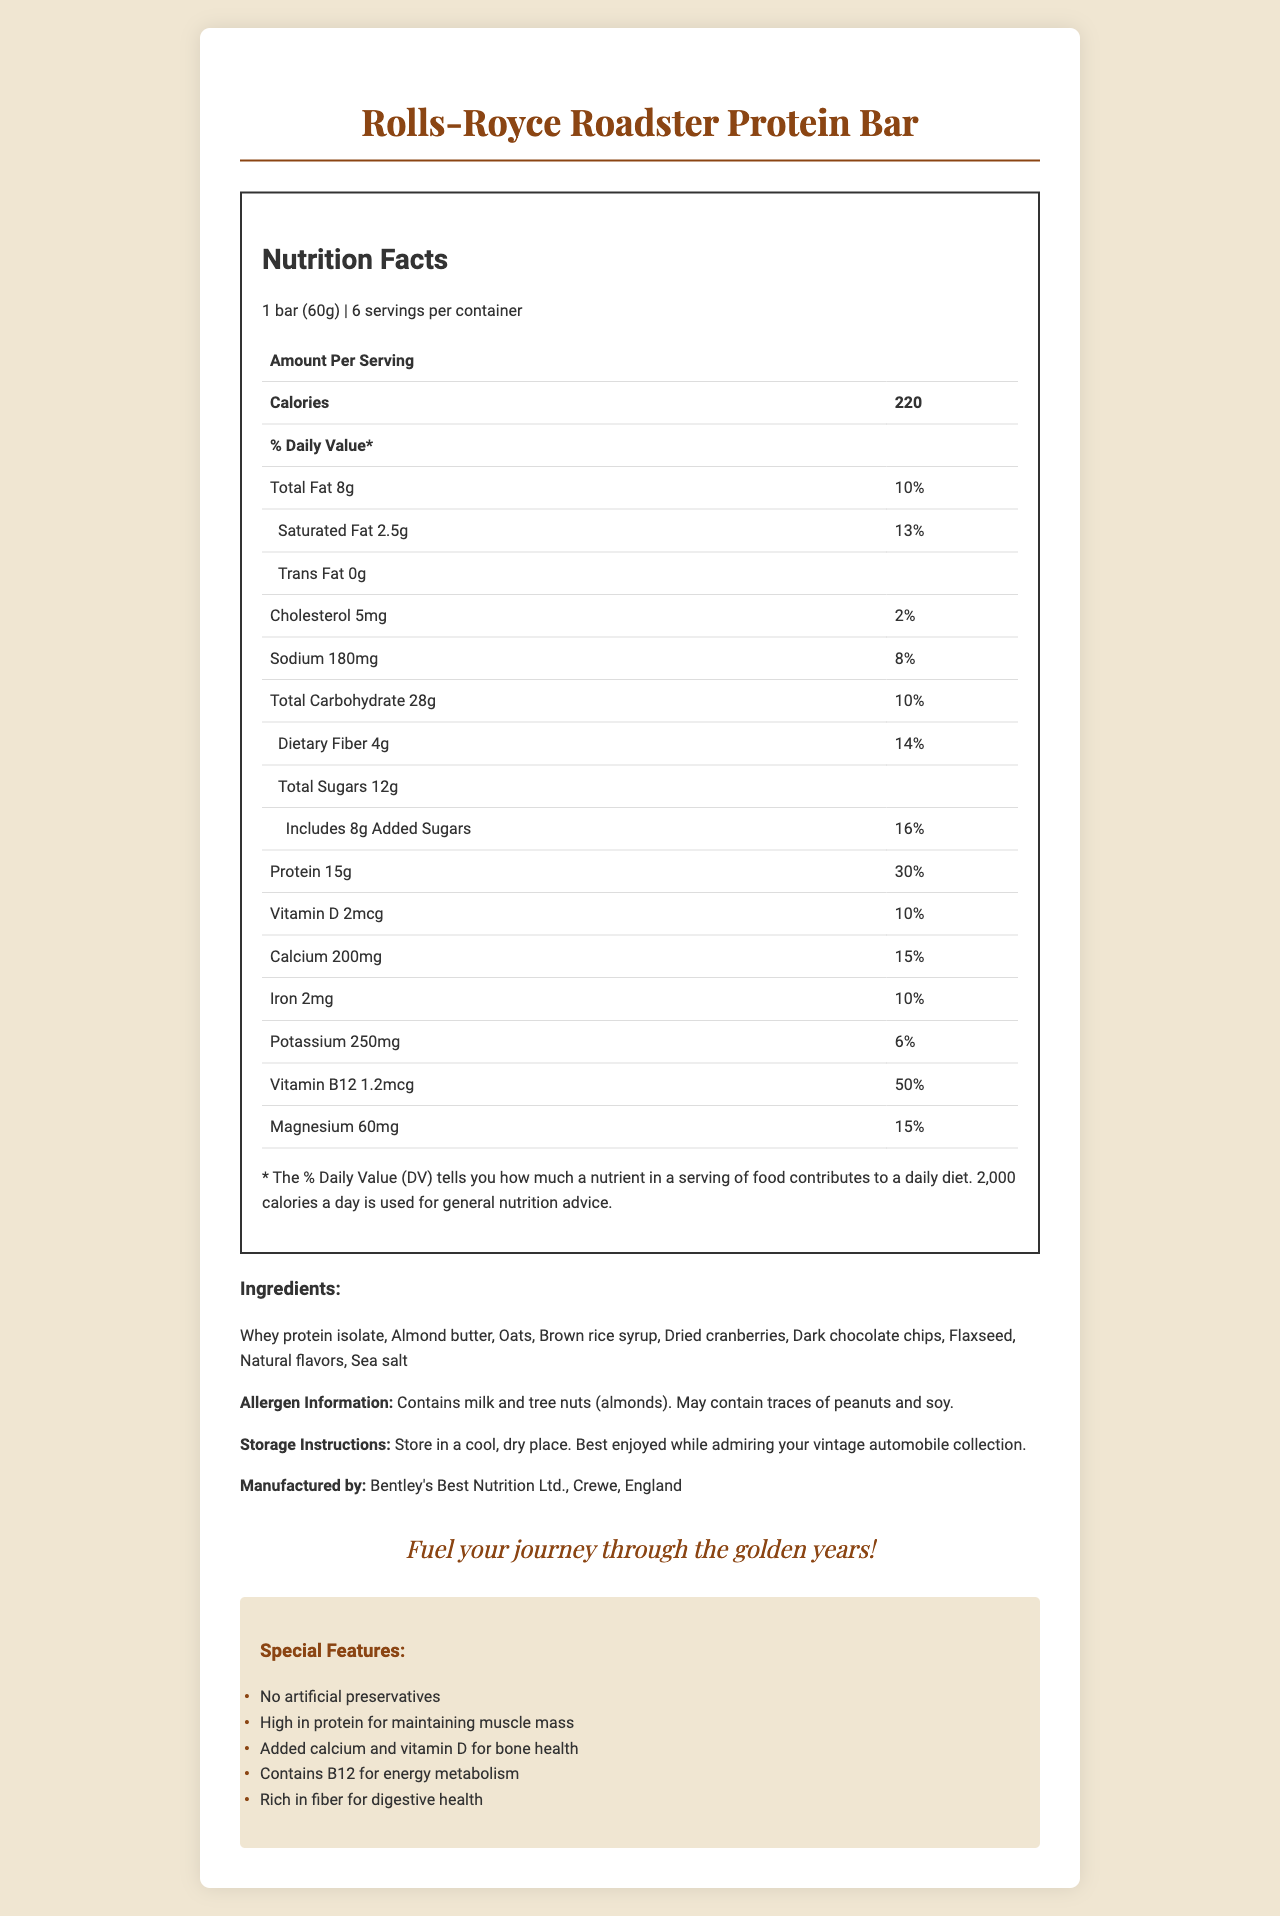what is the serving size for the Rolls-Royce Roadster Protein Bar? The serving size is specified as "1 bar (60g)" in the document.
Answer: 1 bar (60g) how many servings are there per container? The document states there are 6 servings per container.
Answer: 6 what is the amount of protein per serving? The nutrition facts indicate that each serving contains 15g of protein.
Answer: 15g what allergens are contained in this product? The allergen information mentions milk and tree nuts (almonds), and it also may contain traces of peanuts and soy.
Answer: Milk and tree nuts (almonds) how much calcium is there per serving? The document specifies that each serving contains 200mg of calcium.
Answer: 200mg which mineral in the protein bar has the highest daily value percentage? A. Calcium B. Iron C. Potassium D. Magnesium Calcium has the highest daily value percentage at 15%, compared to Iron (10%), Potassium (6%), and Magnesium (15%).
Answer: A. Calcium Which vitamin is described as being crucial for energy metabolism? A. Vitamin D B. Calcium C. Vitamin B12 D. Iron The special features state that Vitamin B12 is included for energy metabolism.
Answer: C. Vitamin B12 is the protein bar free of artificial preservatives? One of the special features of the product is “No artificial preservatives.”
Answer: Yes what is the total fat content per serving? The nutrition label states that the total fat content per serving is 8g.
Answer: 8g what percentage of the daily value for cholesterol does the bar provide? The document specifies that the bar provides 2% of the daily value for cholesterol.
Answer: 2% who manufactures the Rolls-Royce Roadster Protein Bar? The manufacturer information is listed as "Bentley's Best Nutrition Ltd., Crewe, England."
Answer: Bentley's Best Nutrition Ltd., Crewe, England what is the main slogan of this protein bar? The slogan given at the bottom of the document is "Fuel your journey through the golden years!"
Answer: Fuel your journey through the golden years! what are the main ingredients used in this protein bar? The ingredients are listed as: "Whey protein isolate, Almond butter, Oats, Brown rice syrup, Dried cranberries, Dark chocolate chips, Flaxseed, Natural flavors, Sea salt."
Answer: Whey protein isolate, Almond butter, Oats, Brown rice syrup, Dried cranberries, Dark chocolate chips, Flaxseed, Natural flavors, Sea salt how much dietary fiber does one bar contain? The document states that each bar contains 4g of dietary fiber.
Answer: 4g is this protein bar gluten-free? The document does not provide any information regarding whether the bar is gluten-free or not.
Answer: Cannot be determined what is the total amount of sugars per serving? The nutrition label indicates that the total sugars per serving is 12g.
Answer: 12g Summarize the main features of the document in a few sentences. The document includes comprehensive data such as nutrition facts, ingredients, special features, and branding details, aimed at promoting the protein bar as a nutritious and enjoyable snack for older adults.
Answer: The document provides detailed nutrition facts, ingredient information, and special features for the Rolls-Royce Roadster Protein Bar, designed for older adults. Each bar serves as a high-protein snack with added calcium, vitamin D, and B12 for muscle, bone, and energy metabolism. Allergy warnings for milk and tree nuts are mentioned, and the product boasts no artificial preservatives. The slogan and recommended storage instructions emphasize its premium feel, aligning with the target demographic's interests in vintage cars. 